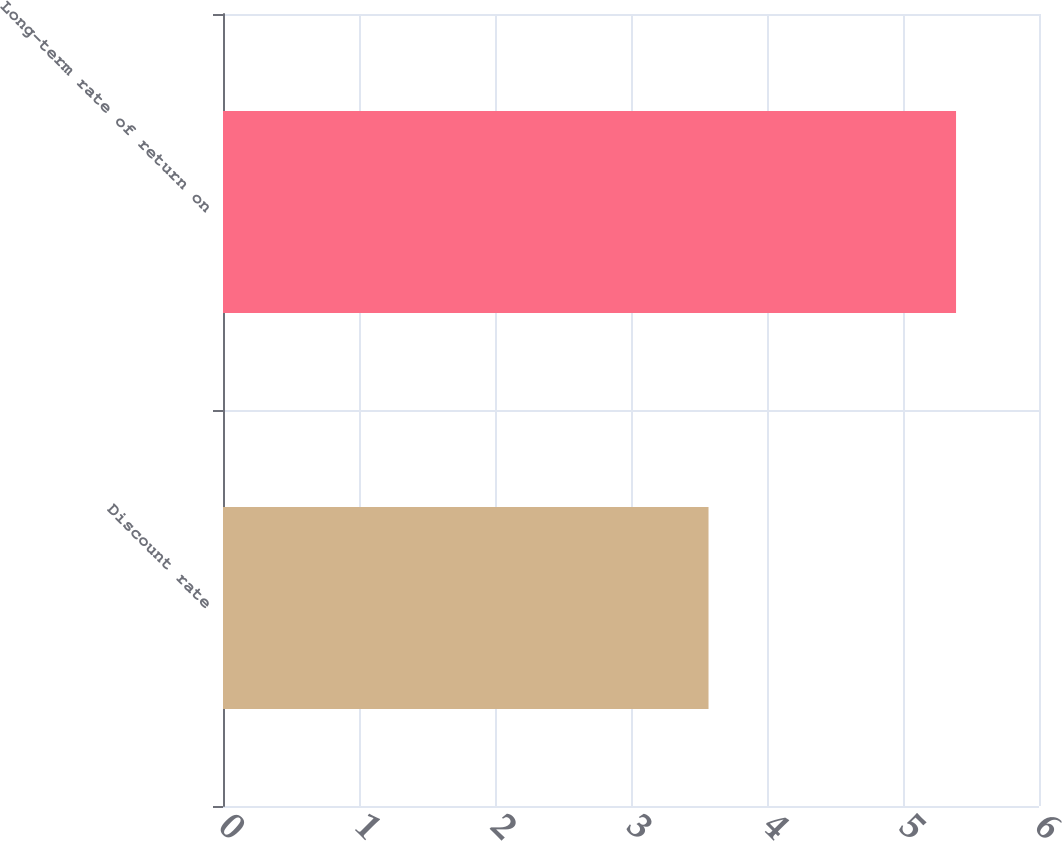Convert chart to OTSL. <chart><loc_0><loc_0><loc_500><loc_500><bar_chart><fcel>Discount rate<fcel>Long-term rate of return on<nl><fcel>3.57<fcel>5.39<nl></chart> 